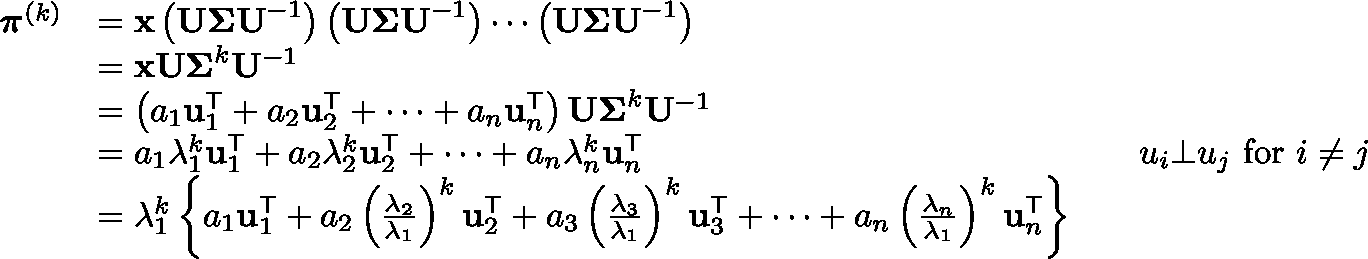<formula> <loc_0><loc_0><loc_500><loc_500>{ \begin{array} { r l r l } { { \pi } ^ { ( k ) } } & { = x \left ( U \Sigma U ^ { - 1 } \right ) \left ( U \Sigma U ^ { - 1 } \right ) \cdots \left ( U \Sigma U ^ { - 1 } \right ) } \\ & { = x U \Sigma ^ { k } U ^ { - 1 } } \\ & { = \left ( a _ { 1 } u _ { 1 } ^ { T } + a _ { 2 } u _ { 2 } ^ { T } + \cdots + a _ { n } u _ { n } ^ { T } \right ) U \Sigma ^ { k } U ^ { - 1 } } \\ & { = a _ { 1 } \lambda _ { 1 } ^ { k } u _ { 1 } ^ { T } + a _ { 2 } \lambda _ { 2 } ^ { k } u _ { 2 } ^ { T } + \cdots + a _ { n } \lambda _ { n } ^ { k } u _ { n } ^ { T } } & & { u _ { i } \bot u _ { j } { f o r } i \neq j } \\ & { = \lambda _ { 1 } ^ { k } \left \{ a _ { 1 } u _ { 1 } ^ { T } + a _ { 2 } \left ( { \frac { \lambda _ { 2 } } { \lambda _ { 1 } } } \right ) ^ { k } u _ { 2 } ^ { T } + a _ { 3 } \left ( { \frac { \lambda _ { 3 } } { \lambda _ { 1 } } } \right ) ^ { k } u _ { 3 } ^ { T } + \cdots + a _ { n } \left ( { \frac { \lambda _ { n } } { \lambda _ { 1 } } } \right ) ^ { k } u _ { n } ^ { T } \right \} } \end{array} }</formula> 